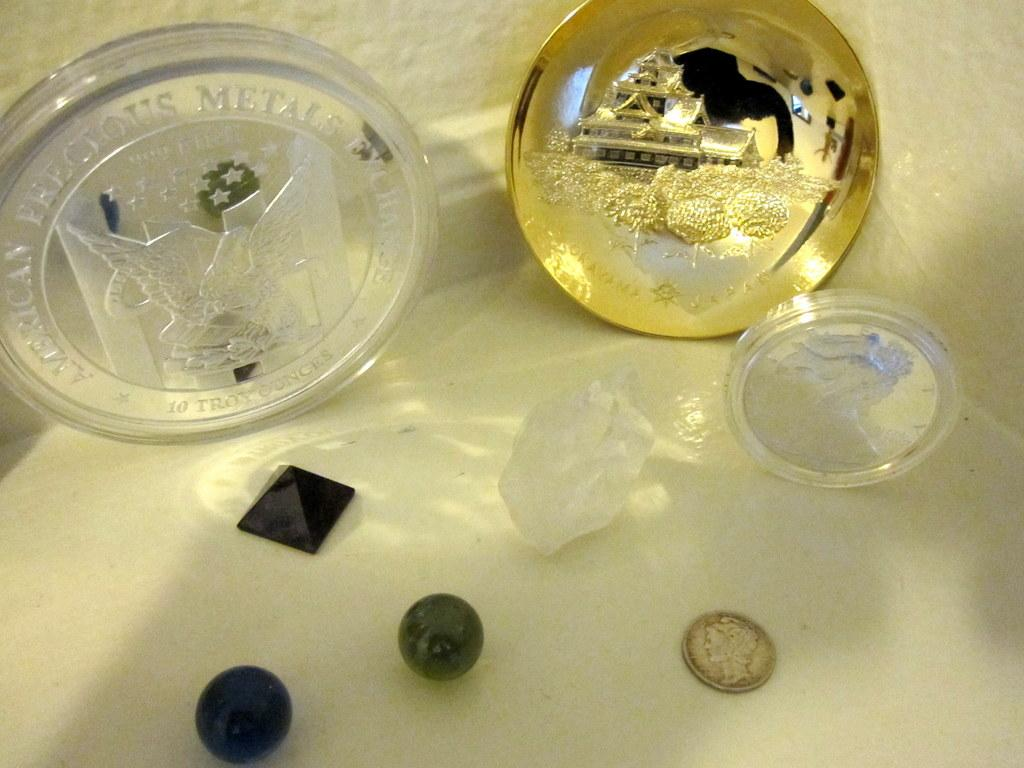<image>
Present a compact description of the photo's key features. An American Precious Metals Exchange glass coin sits on a table with other displayed objects. 